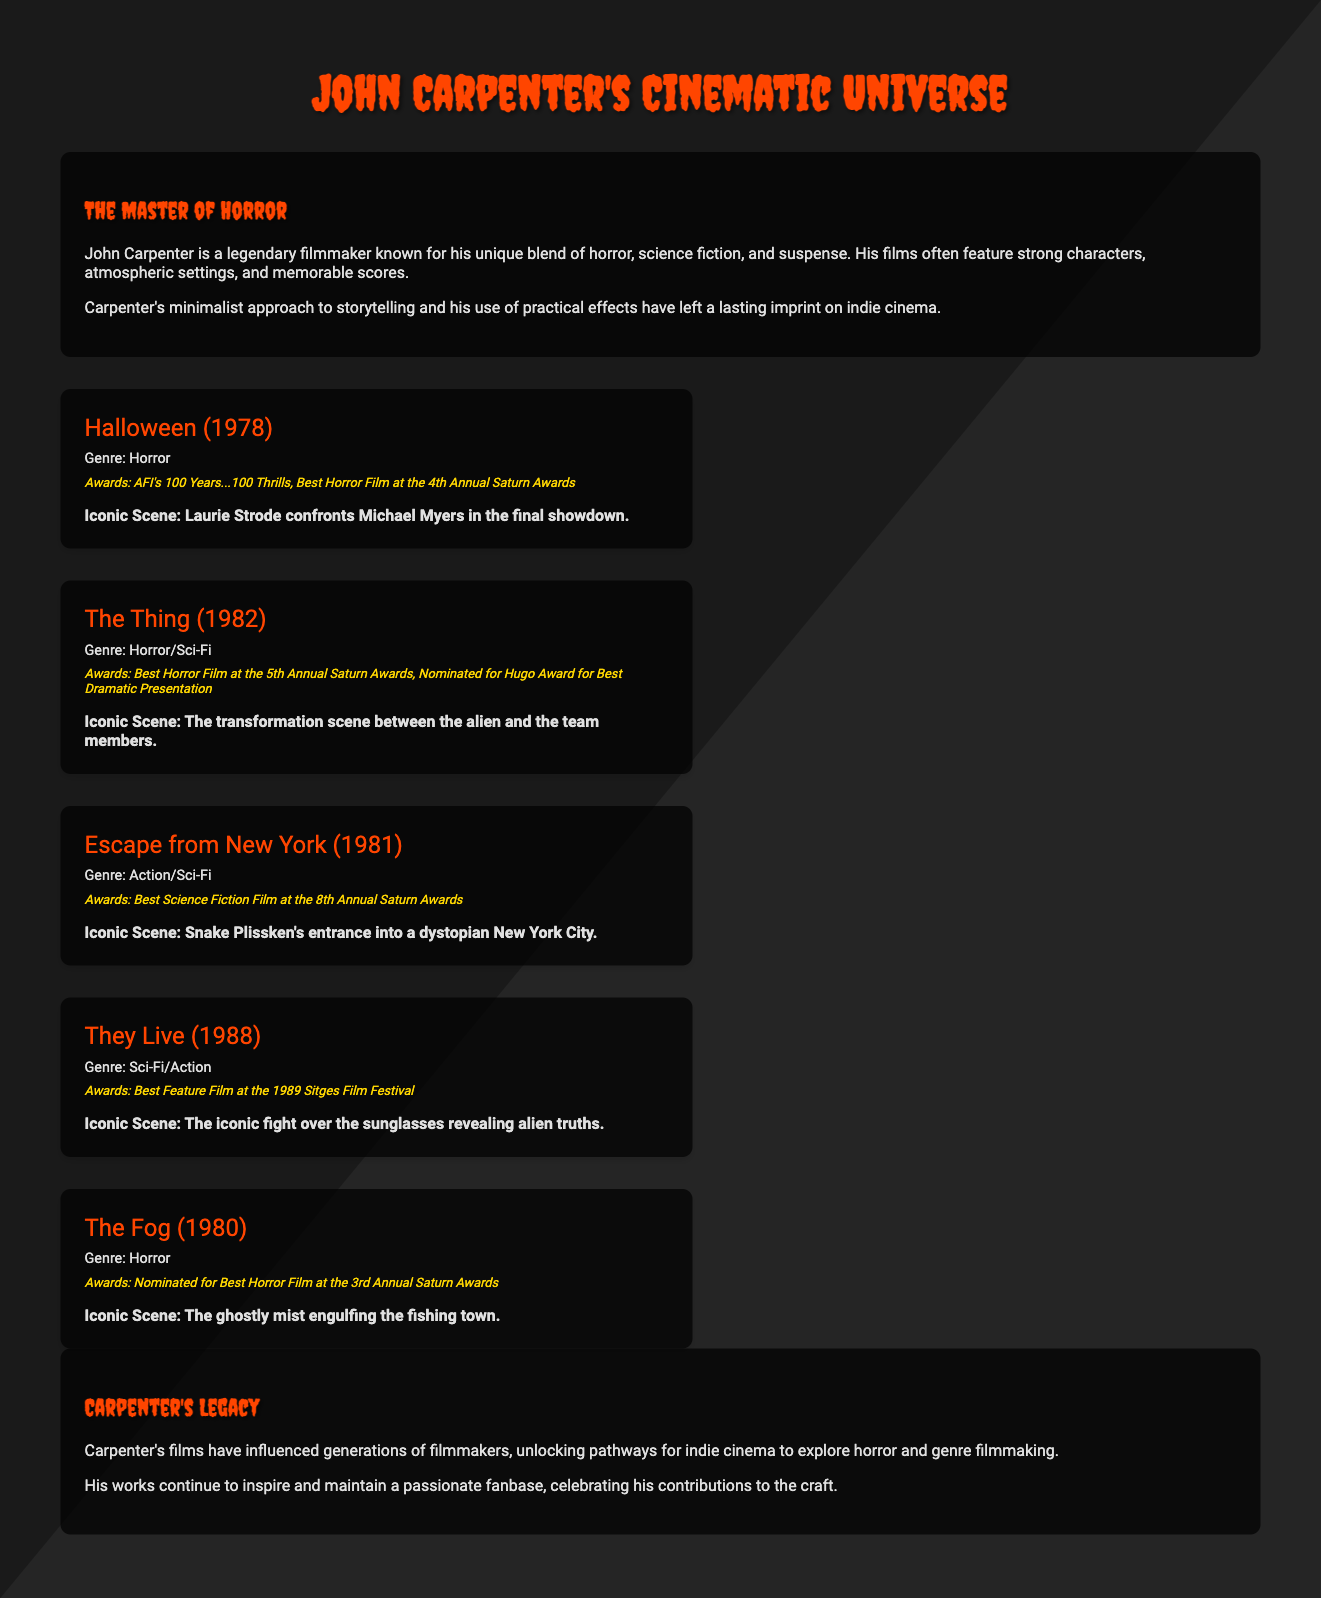What is the genre of Halloween? The genre of Halloween, as mentioned in the film card, is Horror.
Answer: Horror What year was The Thing released? The release year of The Thing is indicated in the document as 1982.
Answer: 1982 Which film won Best Feature Film at the 1989 Sitges Film Festival? They Live is listed as the film that won Best Feature Film at the 1989 Sitges Film Festival.
Answer: They Live What is the iconic scene from Escape from New York? The document specifies that the iconic scene involves Snake Plissken's entrance into a dystopian New York City.
Answer: Snake Plissken's entrance into a dystopian New York City How many films from Carpenter are mentioned in this document? The document lists five films in total, providing details for each one.
Answer: Five What award did The Fog receive? The text mentions that The Fog was nominated for Best Horror Film at the 3rd Annual Saturn Awards.
Answer: Nominated for Best Horror Film at the 3rd Annual Saturn Awards Which film features a fight over alien-revealing sunglasses? They Live is identified in the document as featuring the iconic fight over the sunglasses revealing alien truths.
Answer: They Live What is highlighted as Carpenter's impact on cinema? The conclusion emphasizes that Carpenter's films have influenced generations of filmmakers.
Answer: Influenced generations of filmmakers 